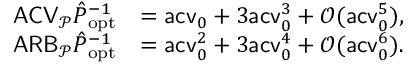Convert formula to latex. <formula><loc_0><loc_0><loc_500><loc_500>\begin{array} { r l } { A C V _ { \mathcal { P } } \hat { P } _ { o p t } ^ { - 1 } } & { = a c v _ { 0 } + 3 a c v _ { 0 } ^ { 3 } + \mathcal { O } ( a c v _ { 0 } ^ { 5 } ) , } \\ { A R B _ { \mathcal { P } } \hat { P } _ { o p t } ^ { - 1 } } & { = a c v _ { 0 } ^ { 2 } + 3 a c v _ { 0 } ^ { 4 } + \mathcal { O } ( a c v _ { 0 } ^ { 6 } ) . } \end{array}</formula> 